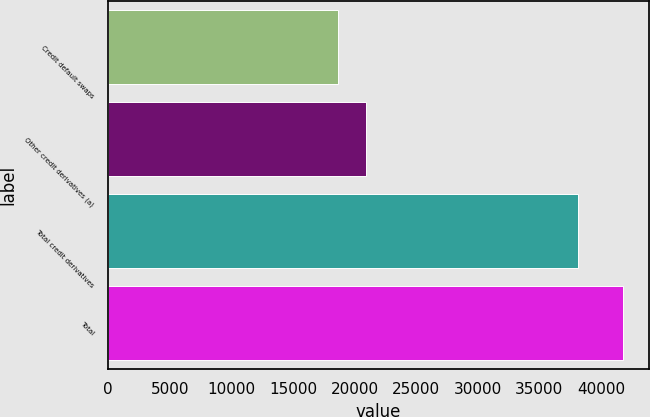<chart> <loc_0><loc_0><loc_500><loc_500><bar_chart><fcel>Credit default swaps<fcel>Other credit derivatives (a)<fcel>Total credit derivatives<fcel>Total<nl><fcel>18631<fcel>20948.9<fcel>38106<fcel>41810<nl></chart> 